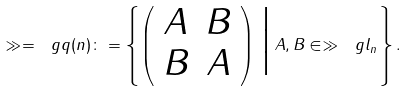Convert formula to latex. <formula><loc_0><loc_0><loc_500><loc_500>\gg = \ g q ( n ) \colon = \left \{ \left ( \begin{array} { c c } A & B \\ B & A \end{array} \right ) \, \Big | \, A , B \in \gg \ g l _ { n } \right \} .</formula> 